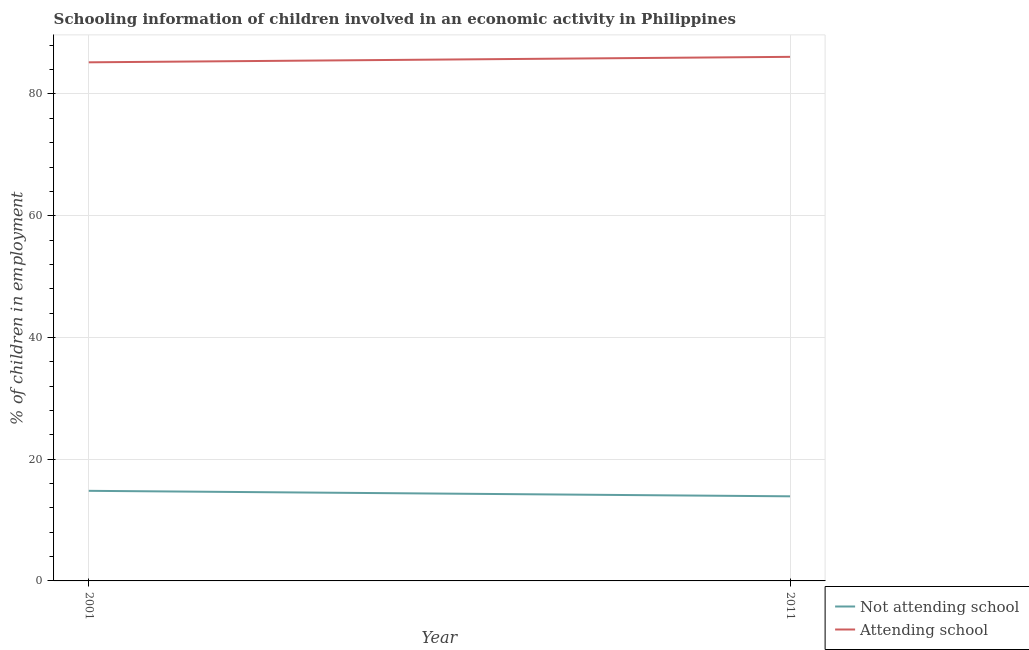How many different coloured lines are there?
Ensure brevity in your answer.  2. Is the number of lines equal to the number of legend labels?
Offer a very short reply. Yes. What is the percentage of employed children who are not attending school in 2001?
Keep it short and to the point. 14.8. Across all years, what is the maximum percentage of employed children who are attending school?
Offer a terse response. 86.1. Across all years, what is the minimum percentage of employed children who are attending school?
Your answer should be very brief. 85.2. What is the total percentage of employed children who are not attending school in the graph?
Give a very brief answer. 28.7. What is the difference between the percentage of employed children who are attending school in 2001 and that in 2011?
Offer a terse response. -0.9. What is the difference between the percentage of employed children who are not attending school in 2011 and the percentage of employed children who are attending school in 2001?
Offer a very short reply. -71.3. What is the average percentage of employed children who are not attending school per year?
Provide a short and direct response. 14.35. In the year 2001, what is the difference between the percentage of employed children who are not attending school and percentage of employed children who are attending school?
Ensure brevity in your answer.  -70.4. What is the ratio of the percentage of employed children who are attending school in 2001 to that in 2011?
Give a very brief answer. 0.99. Is the percentage of employed children who are not attending school in 2001 less than that in 2011?
Give a very brief answer. No. In how many years, is the percentage of employed children who are not attending school greater than the average percentage of employed children who are not attending school taken over all years?
Your answer should be compact. 1. Does the percentage of employed children who are attending school monotonically increase over the years?
Give a very brief answer. Yes. Is the percentage of employed children who are attending school strictly greater than the percentage of employed children who are not attending school over the years?
Make the answer very short. Yes. Is the percentage of employed children who are not attending school strictly less than the percentage of employed children who are attending school over the years?
Give a very brief answer. Yes. How many lines are there?
Keep it short and to the point. 2. How many years are there in the graph?
Make the answer very short. 2. Are the values on the major ticks of Y-axis written in scientific E-notation?
Keep it short and to the point. No. Does the graph contain grids?
Your answer should be compact. Yes. Where does the legend appear in the graph?
Offer a terse response. Bottom right. How many legend labels are there?
Make the answer very short. 2. How are the legend labels stacked?
Offer a very short reply. Vertical. What is the title of the graph?
Offer a very short reply. Schooling information of children involved in an economic activity in Philippines. Does "Register a property" appear as one of the legend labels in the graph?
Your response must be concise. No. What is the label or title of the Y-axis?
Offer a terse response. % of children in employment. What is the % of children in employment in Not attending school in 2001?
Make the answer very short. 14.8. What is the % of children in employment in Attending school in 2001?
Offer a very short reply. 85.2. What is the % of children in employment in Attending school in 2011?
Provide a short and direct response. 86.1. Across all years, what is the maximum % of children in employment in Not attending school?
Provide a succinct answer. 14.8. Across all years, what is the maximum % of children in employment in Attending school?
Make the answer very short. 86.1. Across all years, what is the minimum % of children in employment of Attending school?
Provide a short and direct response. 85.2. What is the total % of children in employment in Not attending school in the graph?
Your answer should be compact. 28.7. What is the total % of children in employment of Attending school in the graph?
Your response must be concise. 171.3. What is the difference between the % of children in employment of Not attending school in 2001 and that in 2011?
Make the answer very short. 0.9. What is the difference between the % of children in employment of Attending school in 2001 and that in 2011?
Offer a very short reply. -0.9. What is the difference between the % of children in employment in Not attending school in 2001 and the % of children in employment in Attending school in 2011?
Provide a succinct answer. -71.3. What is the average % of children in employment in Not attending school per year?
Provide a succinct answer. 14.35. What is the average % of children in employment in Attending school per year?
Offer a very short reply. 85.65. In the year 2001, what is the difference between the % of children in employment in Not attending school and % of children in employment in Attending school?
Offer a very short reply. -70.4. In the year 2011, what is the difference between the % of children in employment of Not attending school and % of children in employment of Attending school?
Keep it short and to the point. -72.2. What is the ratio of the % of children in employment in Not attending school in 2001 to that in 2011?
Your answer should be very brief. 1.06. What is the difference between the highest and the second highest % of children in employment in Not attending school?
Your answer should be compact. 0.9. What is the difference between the highest and the second highest % of children in employment in Attending school?
Ensure brevity in your answer.  0.9. What is the difference between the highest and the lowest % of children in employment in Not attending school?
Your answer should be compact. 0.9. What is the difference between the highest and the lowest % of children in employment of Attending school?
Your answer should be compact. 0.9. 